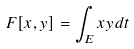Convert formula to latex. <formula><loc_0><loc_0><loc_500><loc_500>F [ x , y ] = \int _ { E } x y d t</formula> 